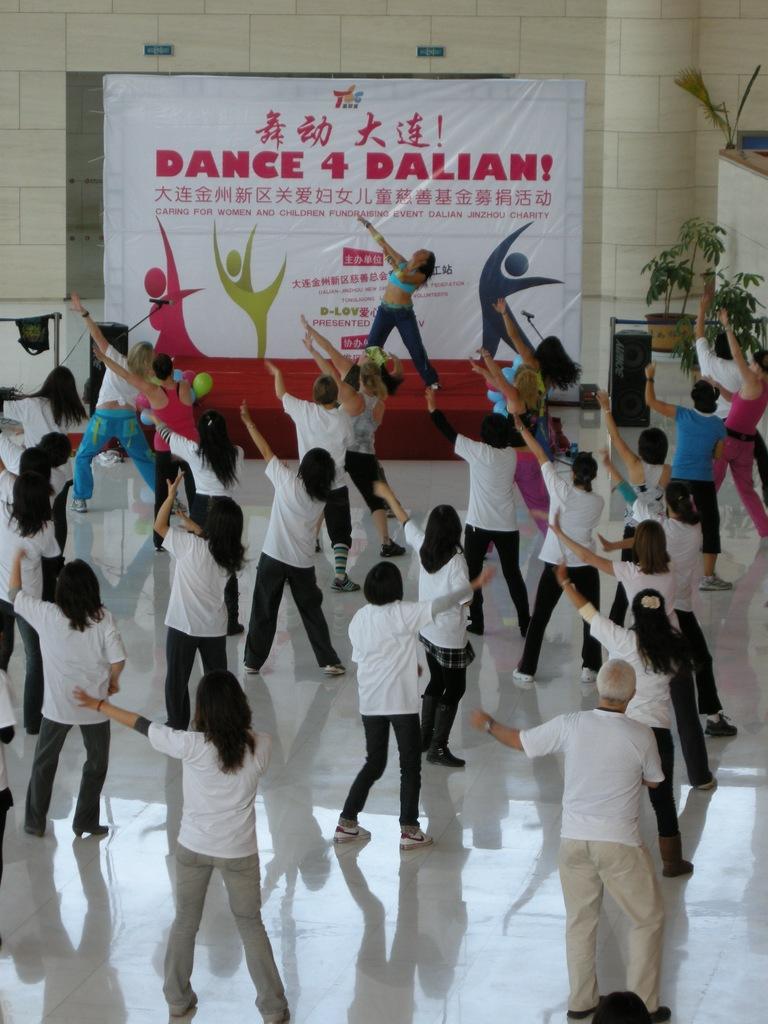Describe this image in one or two sentences. In this image there are a group of people doing yoga in a hall following the instruction of a person on a stage, behind her there is a banner on the wall, also there are some plant pots on the right side. 